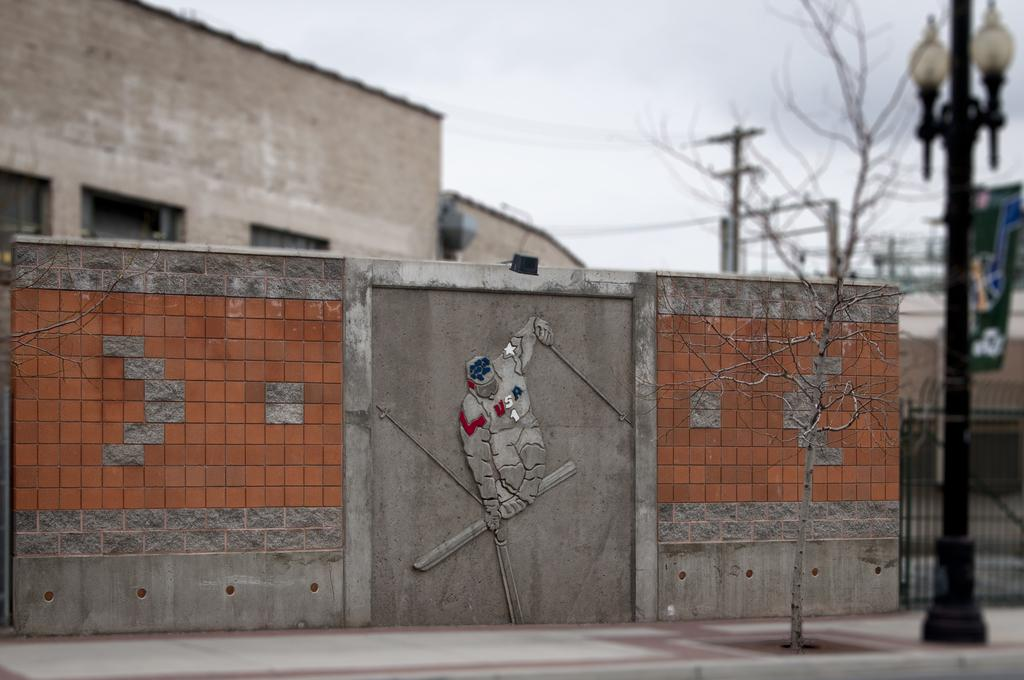What type of tree is at the bottom of the image? There is a bare tree at the bottom of the image. What can be seen on the footpath in the image? There is a light pole on the footpath in the image. What architectural features are present in the image? There is a wall and gate in the image. What type of structures can be seen in the background of the image? There are houses in the background of the image. What specific details can be observed about the houses in the background? There are windows visible in the background of the image. What other objects can be seen in the background of the image? There are poles and trees in the background of the image. What is visible in the background of the image that is not a structure or object? The sky is visible in the background of the image. What type of signage is present in the background of the image? There is a hoarding in the background of the image. What color is the paint on the apparatus in the image? There is no apparatus present in the image, and therefore no paint to describe. How does the image reflect the summer season? The image does not explicitly depict the summer season, and there are no specific details that would indicate the time of year. 